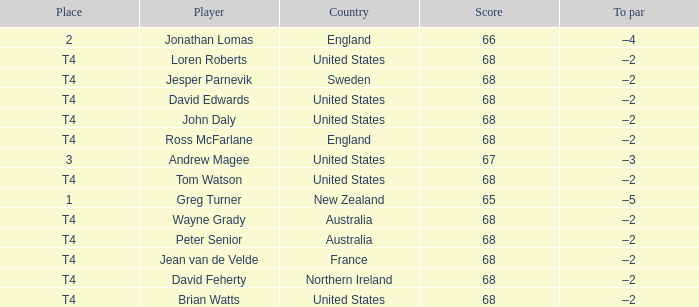Name the Place of england with a Score larger than 66? T4. 